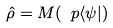<formula> <loc_0><loc_0><loc_500><loc_500>\hat { \rho } = M ( \ p \langle \psi | )</formula> 